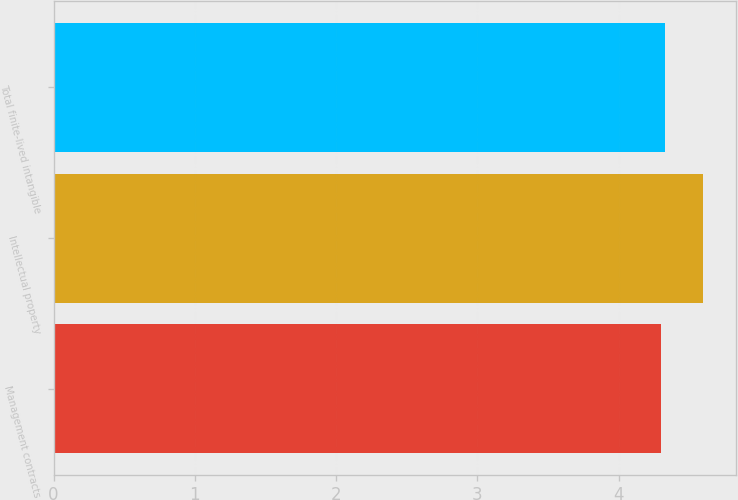Convert chart. <chart><loc_0><loc_0><loc_500><loc_500><bar_chart><fcel>Management contracts<fcel>Intellectual property<fcel>Total finite-lived intangible<nl><fcel>4.3<fcel>4.6<fcel>4.33<nl></chart> 